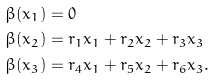<formula> <loc_0><loc_0><loc_500><loc_500>& \beta ( x _ { 1 } ) = 0 \\ & \beta ( x _ { 2 } ) = r _ { 1 } x _ { 1 } + r _ { 2 } x _ { 2 } + r _ { 3 } x _ { 3 } \\ & \beta ( x _ { 3 } ) = r _ { 4 } x _ { 1 } + r _ { 5 } x _ { 2 } + r _ { 6 } x _ { 3 } .</formula> 